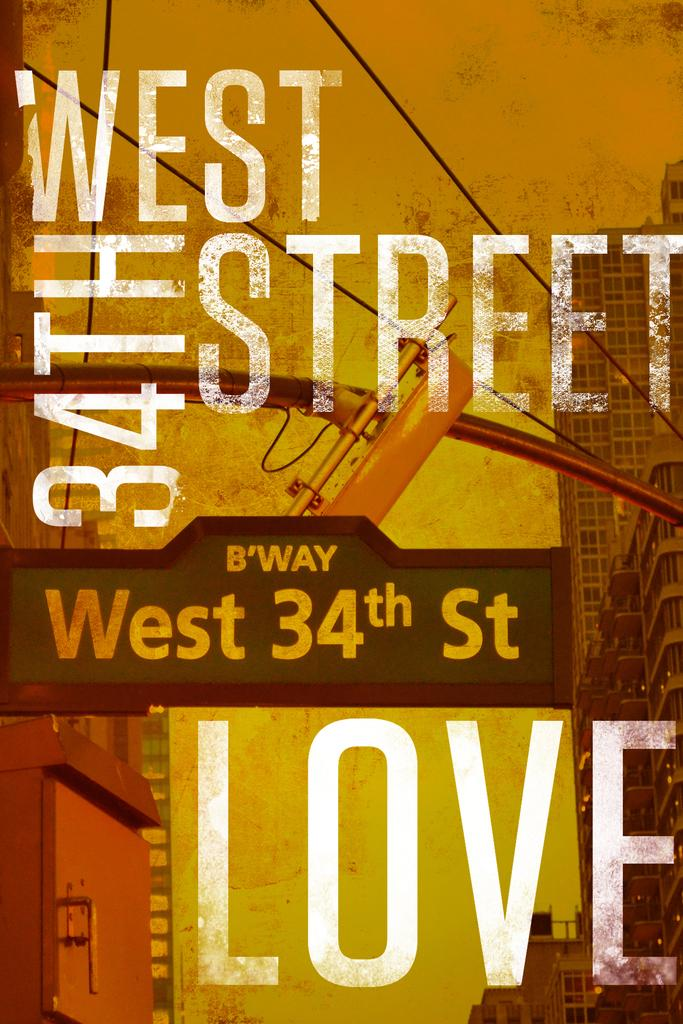<image>
Present a compact description of the photo's key features. A book cover features a sign for B'way and West 34th street. 